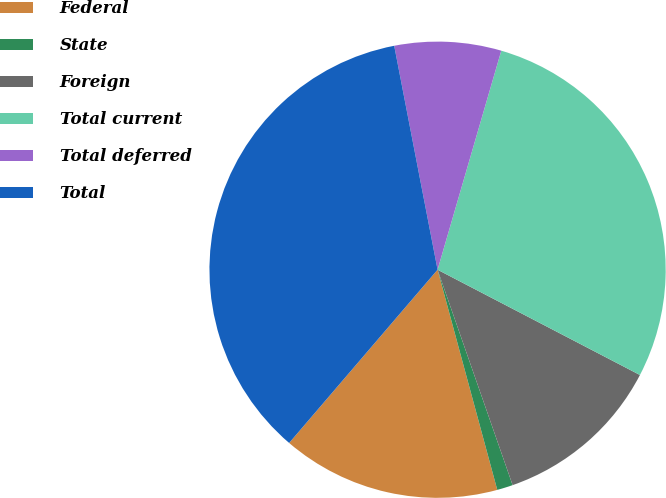Convert chart to OTSL. <chart><loc_0><loc_0><loc_500><loc_500><pie_chart><fcel>Federal<fcel>State<fcel>Foreign<fcel>Total current<fcel>Total deferred<fcel>Total<nl><fcel>15.49%<fcel>1.12%<fcel>12.03%<fcel>28.13%<fcel>7.55%<fcel>35.68%<nl></chart> 